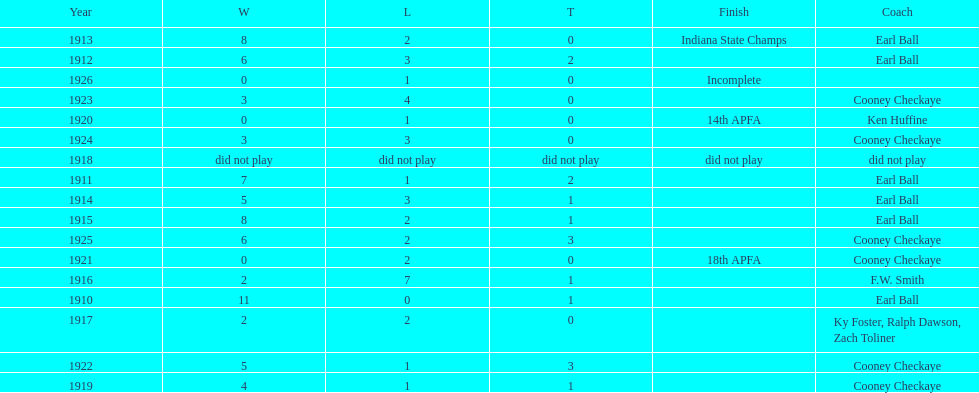Who coached the muncie flyers to an indiana state championship? Earl Ball. 